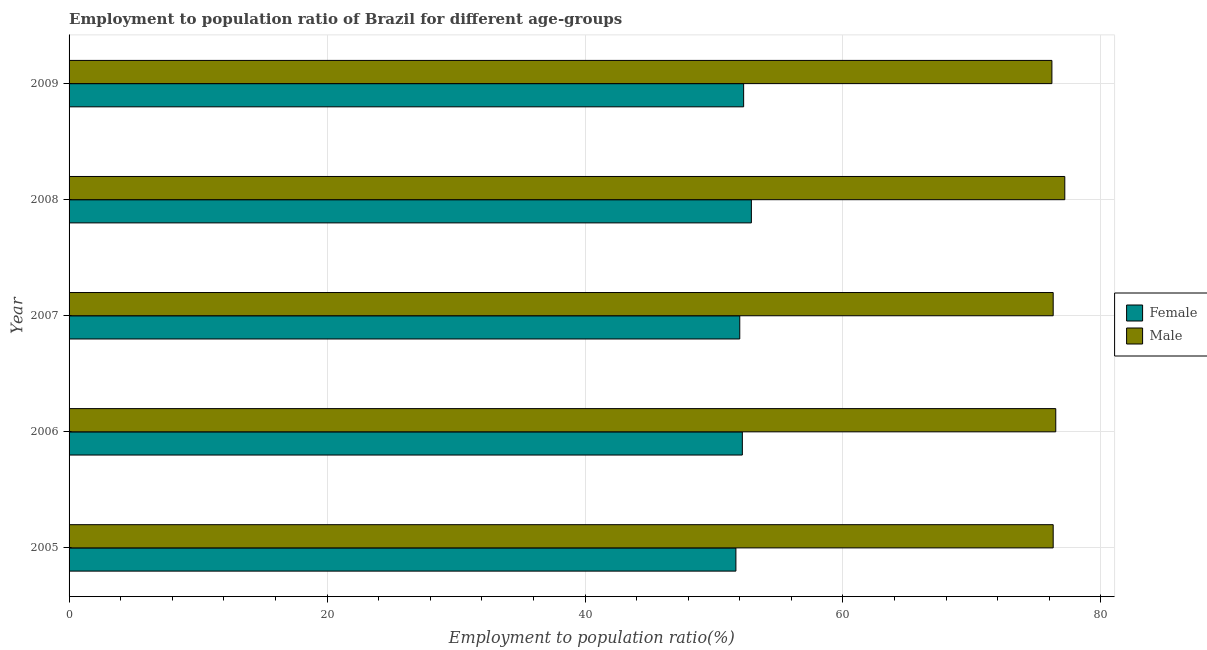How many different coloured bars are there?
Provide a short and direct response. 2. How many groups of bars are there?
Make the answer very short. 5. Are the number of bars per tick equal to the number of legend labels?
Your answer should be compact. Yes. How many bars are there on the 3rd tick from the bottom?
Your answer should be very brief. 2. What is the employment to population ratio(female) in 2007?
Make the answer very short. 52. Across all years, what is the maximum employment to population ratio(male)?
Make the answer very short. 77.2. Across all years, what is the minimum employment to population ratio(female)?
Keep it short and to the point. 51.7. In which year was the employment to population ratio(female) minimum?
Your answer should be compact. 2005. What is the total employment to population ratio(female) in the graph?
Your response must be concise. 261.1. What is the difference between the employment to population ratio(male) in 2006 and that in 2009?
Make the answer very short. 0.3. What is the difference between the employment to population ratio(male) in 2009 and the employment to population ratio(female) in 2007?
Offer a very short reply. 24.2. What is the average employment to population ratio(male) per year?
Keep it short and to the point. 76.5. In the year 2008, what is the difference between the employment to population ratio(female) and employment to population ratio(male)?
Provide a succinct answer. -24.3. In how many years, is the employment to population ratio(female) greater than 20 %?
Your answer should be very brief. 5. Is the employment to population ratio(female) in 2005 less than that in 2007?
Ensure brevity in your answer.  Yes. Is the difference between the employment to population ratio(male) in 2008 and 2009 greater than the difference between the employment to population ratio(female) in 2008 and 2009?
Offer a terse response. Yes. What is the difference between the highest and the lowest employment to population ratio(male)?
Provide a succinct answer. 1. Is the sum of the employment to population ratio(male) in 2008 and 2009 greater than the maximum employment to population ratio(female) across all years?
Give a very brief answer. Yes. How many years are there in the graph?
Your answer should be compact. 5. Does the graph contain grids?
Ensure brevity in your answer.  Yes. What is the title of the graph?
Provide a short and direct response. Employment to population ratio of Brazil for different age-groups. Does "Residents" appear as one of the legend labels in the graph?
Make the answer very short. No. What is the label or title of the X-axis?
Keep it short and to the point. Employment to population ratio(%). What is the Employment to population ratio(%) of Female in 2005?
Your answer should be very brief. 51.7. What is the Employment to population ratio(%) in Male in 2005?
Keep it short and to the point. 76.3. What is the Employment to population ratio(%) of Female in 2006?
Offer a very short reply. 52.2. What is the Employment to population ratio(%) of Male in 2006?
Offer a terse response. 76.5. What is the Employment to population ratio(%) of Male in 2007?
Your response must be concise. 76.3. What is the Employment to population ratio(%) in Female in 2008?
Give a very brief answer. 52.9. What is the Employment to population ratio(%) in Male in 2008?
Keep it short and to the point. 77.2. What is the Employment to population ratio(%) of Female in 2009?
Offer a very short reply. 52.3. What is the Employment to population ratio(%) of Male in 2009?
Ensure brevity in your answer.  76.2. Across all years, what is the maximum Employment to population ratio(%) in Female?
Ensure brevity in your answer.  52.9. Across all years, what is the maximum Employment to population ratio(%) in Male?
Offer a very short reply. 77.2. Across all years, what is the minimum Employment to population ratio(%) in Female?
Give a very brief answer. 51.7. Across all years, what is the minimum Employment to population ratio(%) in Male?
Ensure brevity in your answer.  76.2. What is the total Employment to population ratio(%) in Female in the graph?
Provide a short and direct response. 261.1. What is the total Employment to population ratio(%) of Male in the graph?
Make the answer very short. 382.5. What is the difference between the Employment to population ratio(%) in Female in 2005 and that in 2006?
Offer a very short reply. -0.5. What is the difference between the Employment to population ratio(%) of Male in 2005 and that in 2006?
Ensure brevity in your answer.  -0.2. What is the difference between the Employment to population ratio(%) in Female in 2005 and that in 2007?
Your response must be concise. -0.3. What is the difference between the Employment to population ratio(%) of Male in 2005 and that in 2007?
Keep it short and to the point. 0. What is the difference between the Employment to population ratio(%) of Female in 2005 and that in 2008?
Provide a succinct answer. -1.2. What is the difference between the Employment to population ratio(%) of Female in 2005 and that in 2009?
Provide a succinct answer. -0.6. What is the difference between the Employment to population ratio(%) in Male in 2005 and that in 2009?
Your response must be concise. 0.1. What is the difference between the Employment to population ratio(%) of Female in 2006 and that in 2007?
Your response must be concise. 0.2. What is the difference between the Employment to population ratio(%) in Male in 2006 and that in 2009?
Your response must be concise. 0.3. What is the difference between the Employment to population ratio(%) in Male in 2007 and that in 2008?
Your answer should be compact. -0.9. What is the difference between the Employment to population ratio(%) in Female in 2007 and that in 2009?
Offer a very short reply. -0.3. What is the difference between the Employment to population ratio(%) in Male in 2007 and that in 2009?
Offer a very short reply. 0.1. What is the difference between the Employment to population ratio(%) of Male in 2008 and that in 2009?
Your response must be concise. 1. What is the difference between the Employment to population ratio(%) of Female in 2005 and the Employment to population ratio(%) of Male in 2006?
Provide a short and direct response. -24.8. What is the difference between the Employment to population ratio(%) of Female in 2005 and the Employment to population ratio(%) of Male in 2007?
Your answer should be very brief. -24.6. What is the difference between the Employment to population ratio(%) of Female in 2005 and the Employment to population ratio(%) of Male in 2008?
Provide a short and direct response. -25.5. What is the difference between the Employment to population ratio(%) in Female in 2005 and the Employment to population ratio(%) in Male in 2009?
Provide a short and direct response. -24.5. What is the difference between the Employment to population ratio(%) in Female in 2006 and the Employment to population ratio(%) in Male in 2007?
Offer a terse response. -24.1. What is the difference between the Employment to population ratio(%) in Female in 2006 and the Employment to population ratio(%) in Male in 2008?
Offer a terse response. -25. What is the difference between the Employment to population ratio(%) in Female in 2006 and the Employment to population ratio(%) in Male in 2009?
Offer a very short reply. -24. What is the difference between the Employment to population ratio(%) of Female in 2007 and the Employment to population ratio(%) of Male in 2008?
Your answer should be compact. -25.2. What is the difference between the Employment to population ratio(%) in Female in 2007 and the Employment to population ratio(%) in Male in 2009?
Your response must be concise. -24.2. What is the difference between the Employment to population ratio(%) of Female in 2008 and the Employment to population ratio(%) of Male in 2009?
Offer a very short reply. -23.3. What is the average Employment to population ratio(%) in Female per year?
Offer a very short reply. 52.22. What is the average Employment to population ratio(%) in Male per year?
Your answer should be very brief. 76.5. In the year 2005, what is the difference between the Employment to population ratio(%) in Female and Employment to population ratio(%) in Male?
Provide a short and direct response. -24.6. In the year 2006, what is the difference between the Employment to population ratio(%) in Female and Employment to population ratio(%) in Male?
Make the answer very short. -24.3. In the year 2007, what is the difference between the Employment to population ratio(%) of Female and Employment to population ratio(%) of Male?
Ensure brevity in your answer.  -24.3. In the year 2008, what is the difference between the Employment to population ratio(%) of Female and Employment to population ratio(%) of Male?
Make the answer very short. -24.3. In the year 2009, what is the difference between the Employment to population ratio(%) in Female and Employment to population ratio(%) in Male?
Your answer should be very brief. -23.9. What is the ratio of the Employment to population ratio(%) in Female in 2005 to that in 2006?
Make the answer very short. 0.99. What is the ratio of the Employment to population ratio(%) in Male in 2005 to that in 2006?
Make the answer very short. 1. What is the ratio of the Employment to population ratio(%) of Female in 2005 to that in 2007?
Your answer should be very brief. 0.99. What is the ratio of the Employment to population ratio(%) in Male in 2005 to that in 2007?
Your answer should be compact. 1. What is the ratio of the Employment to population ratio(%) in Female in 2005 to that in 2008?
Ensure brevity in your answer.  0.98. What is the ratio of the Employment to population ratio(%) of Male in 2005 to that in 2008?
Give a very brief answer. 0.99. What is the ratio of the Employment to population ratio(%) of Female in 2005 to that in 2009?
Make the answer very short. 0.99. What is the ratio of the Employment to population ratio(%) of Male in 2006 to that in 2008?
Provide a short and direct response. 0.99. What is the ratio of the Employment to population ratio(%) in Female in 2006 to that in 2009?
Ensure brevity in your answer.  1. What is the ratio of the Employment to population ratio(%) in Male in 2007 to that in 2008?
Keep it short and to the point. 0.99. What is the ratio of the Employment to population ratio(%) of Female in 2007 to that in 2009?
Offer a terse response. 0.99. What is the ratio of the Employment to population ratio(%) of Female in 2008 to that in 2009?
Your answer should be very brief. 1.01. What is the ratio of the Employment to population ratio(%) of Male in 2008 to that in 2009?
Your answer should be compact. 1.01. What is the difference between the highest and the second highest Employment to population ratio(%) of Female?
Provide a short and direct response. 0.6. What is the difference between the highest and the second highest Employment to population ratio(%) of Male?
Provide a short and direct response. 0.7. What is the difference between the highest and the lowest Employment to population ratio(%) of Female?
Provide a short and direct response. 1.2. What is the difference between the highest and the lowest Employment to population ratio(%) of Male?
Ensure brevity in your answer.  1. 